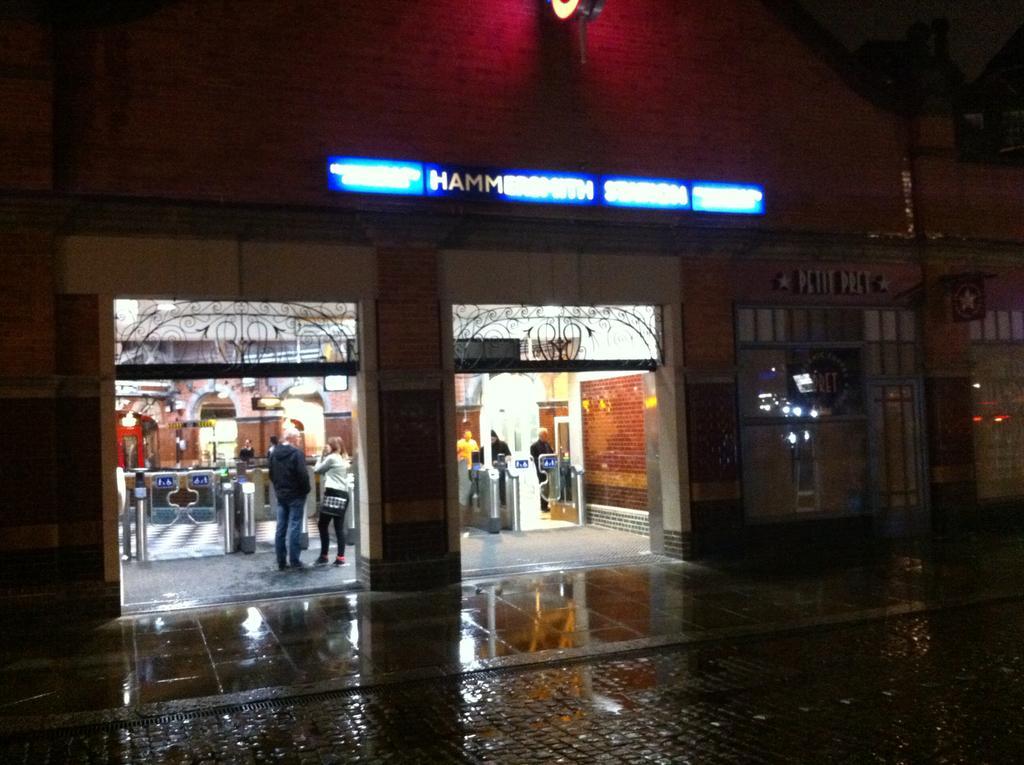How would you summarize this image in a sentence or two? This picture is inside view of a room. Here we can see access control gates and some persons are there. At the top of the image naming board, wall, light are present. At the bottom of the image floor is there. In the middle of the image wall is present. 